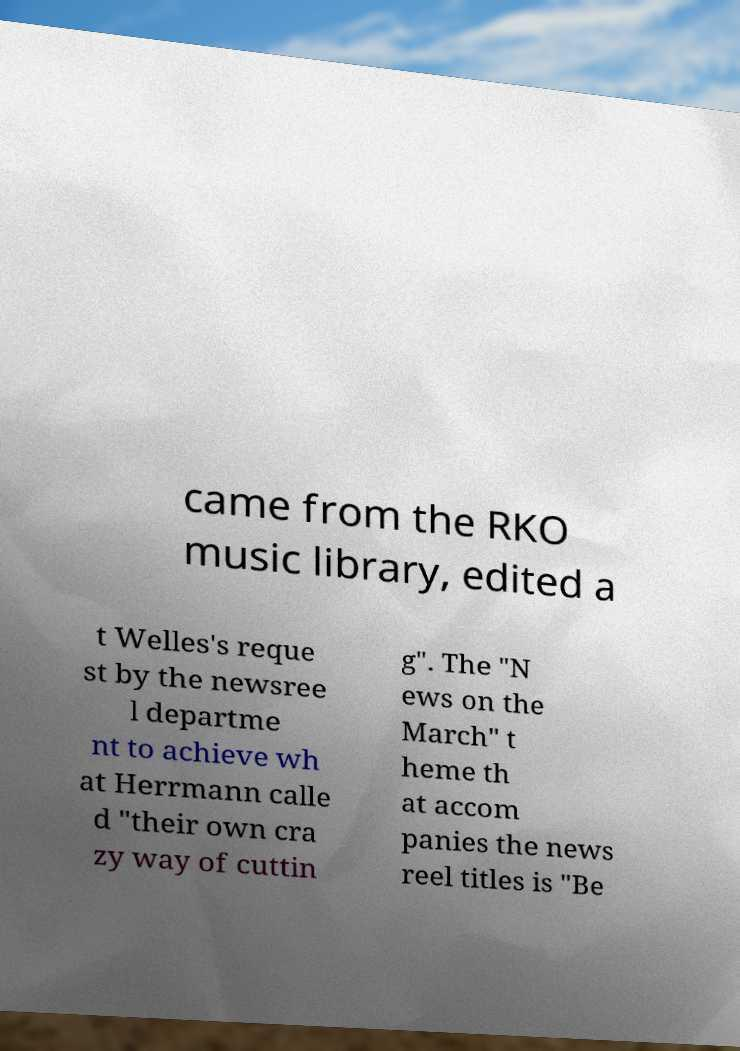For documentation purposes, I need the text within this image transcribed. Could you provide that? came from the RKO music library, edited a t Welles's reque st by the newsree l departme nt to achieve wh at Herrmann calle d "their own cra zy way of cuttin g". The "N ews on the March" t heme th at accom panies the news reel titles is "Be 